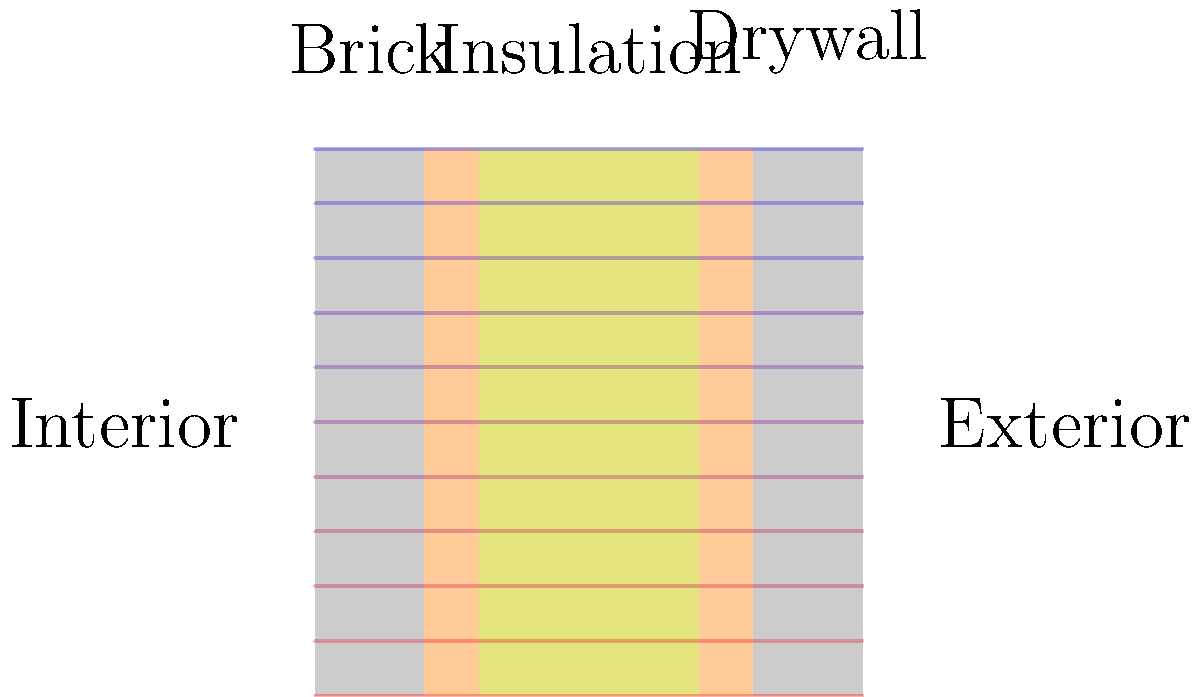As a community leader advocating for better housing conditions in Elephant & Castle, you're assessing the effectiveness of different insulation materials. The diagram shows a wall cross-section with brick, insulation, and drywall layers. If the R-value of the insulation layer is doubled, how would this affect the heat flow through the wall, assuming all other factors remain constant? To understand the effect of doubling the R-value of the insulation layer, let's follow these steps:

1. Understand R-value: R-value measures thermal resistance. Higher R-value means better insulation.

2. Recall the heat flow equation: 
   $$Q = \frac{A \Delta T}{R}$$
   Where Q is heat flow, A is area, ΔT is temperature difference, and R is total thermal resistance.

3. Analyze the current situation:
   The total R-value of the wall is the sum of R-values of all layers.
   $$R_{total} = R_{brick} + R_{insulation} + R_{drywall}$$

4. Consider doubling the R-value of insulation:
   $$R_{new\_total} = R_{brick} + 2R_{insulation} + R_{drywall}$$

5. Compare heat flow:
   Current heat flow: $$Q_1 = \frac{A \Delta T}{R_{total}}$$
   New heat flow: $$Q_2 = \frac{A \Delta T}{R_{new\_total}}$$

6. Since $R_{new\_total} > R_{total}$, we can conclude that $Q_2 < Q_1$.

7. The percentage reduction in heat flow can be calculated as:
   $$\text{Reduction} = \frac{Q_1 - Q_2}{Q_1} \times 100\%$$

8. The exact reduction depends on the initial R-values of each layer, but it will be less than 50% as only the insulation layer's R-value is doubled, not the entire wall's R-value.
Answer: Heat flow through the wall will decrease, but by less than 50%. 